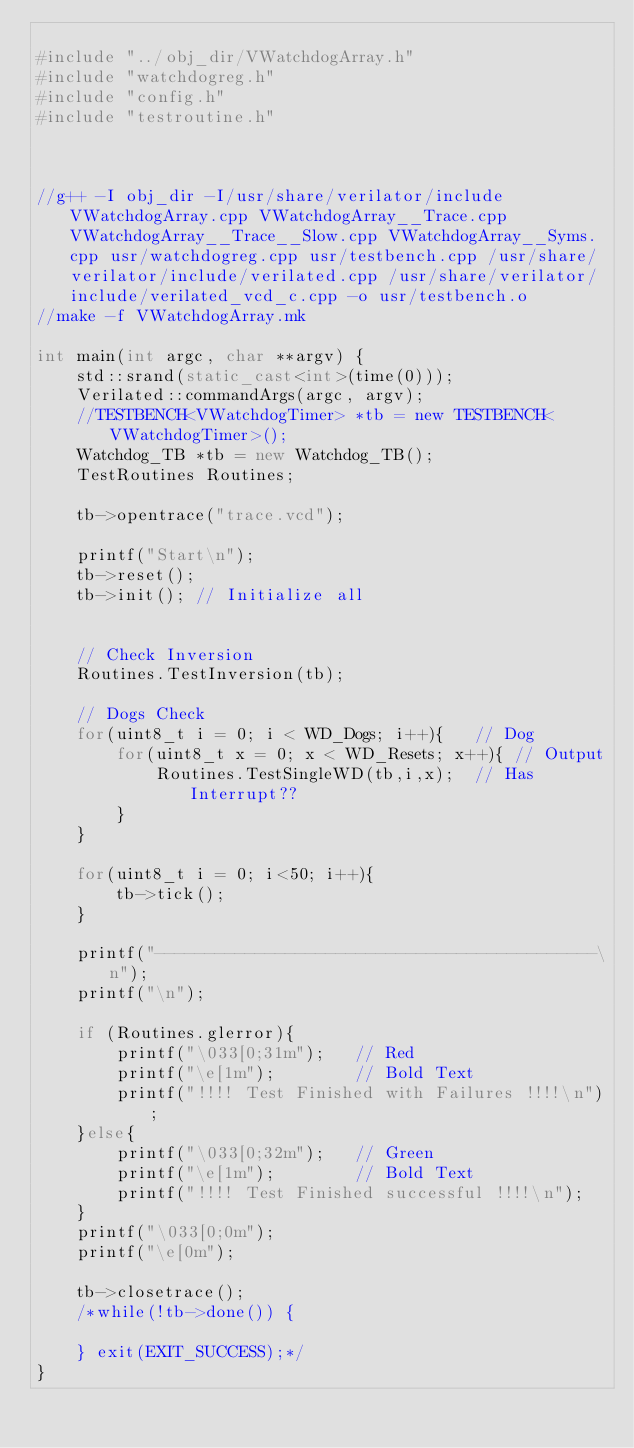Convert code to text. <code><loc_0><loc_0><loc_500><loc_500><_C++_>
#include "../obj_dir/VWatchdogArray.h"
#include "watchdogreg.h"
#include "config.h"
#include "testroutine.h"



//g++ -I obj_dir -I/usr/share/verilator/include VWatchdogArray.cpp VWatchdogArray__Trace.cpp VWatchdogArray__Trace__Slow.cpp VWatchdogArray__Syms.cpp usr/watchdogreg.cpp usr/testbench.cpp /usr/share/verilator/include/verilated.cpp /usr/share/verilator/include/verilated_vcd_c.cpp -o usr/testbench.o
//make -f VWatchdogArray.mk   

int main(int argc, char **argv) {
	std::srand(static_cast<int>(time(0)));
	Verilated::commandArgs(argc, argv);
	//TESTBENCH<VWatchdogTimer> *tb = new TESTBENCH<VWatchdogTimer>();
	Watchdog_TB *tb = new Watchdog_TB();
	TestRoutines Routines;

	tb->opentrace("trace.vcd");

	printf("Start\n");
	tb->reset();
	tb->init();	// Initialize all


	// Check Inversion
	Routines.TestInversion(tb);

	// Dogs Check
	for(uint8_t i = 0; i < WD_Dogs; i++){	// Dog
		for(uint8_t x = 0; x < WD_Resets; x++){	// Output
			Routines.TestSingleWD(tb,i,x);	// Has Interrupt??
		}
	}

	for(uint8_t i = 0; i<50; i++){
		tb->tick();
	}
	
	printf("--------------------------------------------\n");
	printf("\n");
	
	if (Routines.glerror){
		printf("\033[0;31m");	// Red
		printf("\e[1m");		// Bold Text
		printf("!!!! Test Finished with Failures !!!!\n");
	}else{
		printf("\033[0;32m");	// Green
		printf("\e[1m");		// Bold Text
		printf("!!!! Test Finished successful !!!!\n");
	}
	printf("\033[0;0m");
	printf("\e[0m");
	
	tb->closetrace();
	/*while(!tb->done()) {
		
	} exit(EXIT_SUCCESS);*/
}

</code> 